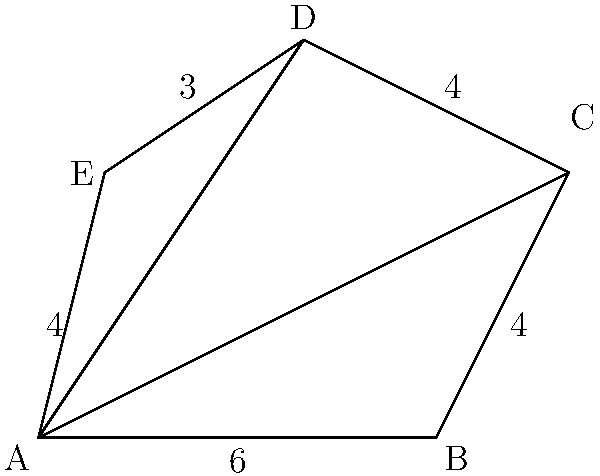Calculate the area of the irregular pentagon ABCDE using triangulation techniques. Given that AB = 6, BC = 4, CD = 4, DE = 3, and EA = 4 units. To calculate the area of the irregular pentagon ABCDE, we'll use triangulation by dividing it into three triangles: ABC, ACD, and ADE. We'll then calculate the area of each triangle and sum them up.

Step 1: Calculate the area of triangle ABC
We know AB = 6 and BC = 4. We need to find the height of this triangle.
Using the Pythagorean theorem in triangle ABC:
$$ AC^2 = AB^2 + BC^2 = 6^2 + 4^2 = 52 $$
$$ AC = \sqrt{52} = 2\sqrt{13} $$

Now, we can calculate the height (h) of triangle ABC:
$$ h^2 + 3^2 = (\frac{1}{2}\sqrt{52})^2 $$
$$ h^2 = \frac{52}{4} - 9 = 4 $$
$$ h = 2 $$

Area of triangle ABC = $\frac{1}{2} \times 6 \times 2 = 6$ square units

Step 2: Calculate the area of triangle ACD
We can use Heron's formula for this triangle. Half-perimeter (s):
$$ s = \frac{AC + CD + AD}{2} = \frac{2\sqrt{13} + 4 + 6}{2} = 5 + \sqrt{13} $$

Area of triangle ACD:
$$ \sqrt{s(s-AC)(s-CD)(s-AD)} $$
$$ = \sqrt{(5+\sqrt{13})(5+\sqrt{13}-2\sqrt{13})(5+\sqrt{13}-4)(5+\sqrt{13}-6)} $$
$$ = \sqrt{(5+\sqrt{13})(5-\sqrt{13})(1+\sqrt{13})(-1+\sqrt{13})} $$
$$ = \sqrt{(25-13)(1-13)} = \sqrt{12 \times (-12)} = 12 $$ square units

Step 3: Calculate the area of triangle ADE
Using Heron's formula again. Half-perimeter (s):
$$ s = \frac{6 + 3 + 4}{2} = 6.5 $$

Area of triangle ADE:
$$ \sqrt{s(s-AD)(s-DE)(s-EA)} $$
$$ = \sqrt{6.5(6.5-6)(6.5-3)(6.5-4)} $$
$$ = \sqrt{6.5 \times 0.5 \times 3.5 \times 2.5} $$
$$ = \sqrt{28.4375} \approx 5.33 $$ square units

Step 4: Sum up the areas of all triangles
Total area = Area of ABC + Area of ACD + Area of ADE
$$ 6 + 12 + 5.33 = 23.33 $$ square units
Answer: 23.33 square units 